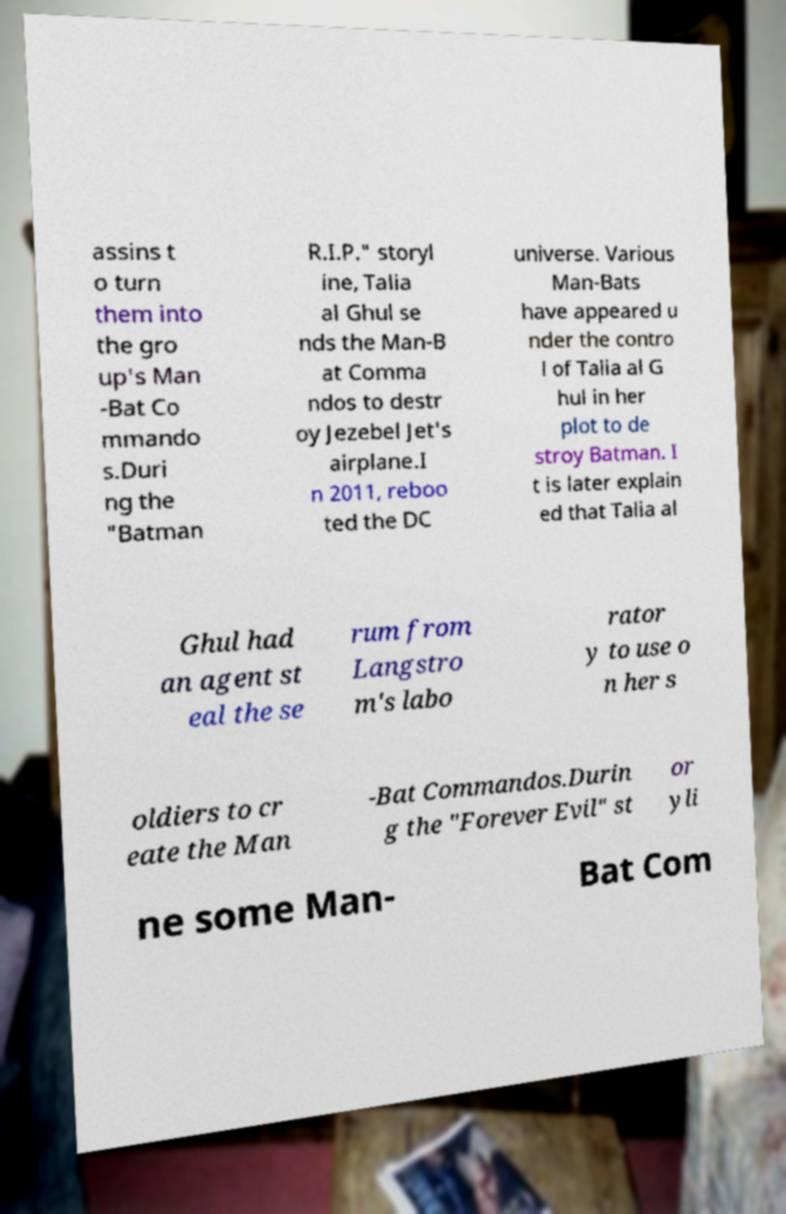There's text embedded in this image that I need extracted. Can you transcribe it verbatim? assins t o turn them into the gro up's Man -Bat Co mmando s.Duri ng the "Batman R.I.P." storyl ine, Talia al Ghul se nds the Man-B at Comma ndos to destr oy Jezebel Jet's airplane.I n 2011, reboo ted the DC universe. Various Man-Bats have appeared u nder the contro l of Talia al G hul in her plot to de stroy Batman. I t is later explain ed that Talia al Ghul had an agent st eal the se rum from Langstro m's labo rator y to use o n her s oldiers to cr eate the Man -Bat Commandos.Durin g the "Forever Evil" st or yli ne some Man- Bat Com 